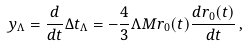Convert formula to latex. <formula><loc_0><loc_0><loc_500><loc_500>y _ { \Lambda } = \frac { d } { d t } \Delta t _ { \Lambda } = - \frac { 4 } { 3 } \Lambda M r _ { 0 } ( t ) \frac { d r _ { 0 } ( t ) } { d t } \, ,</formula> 